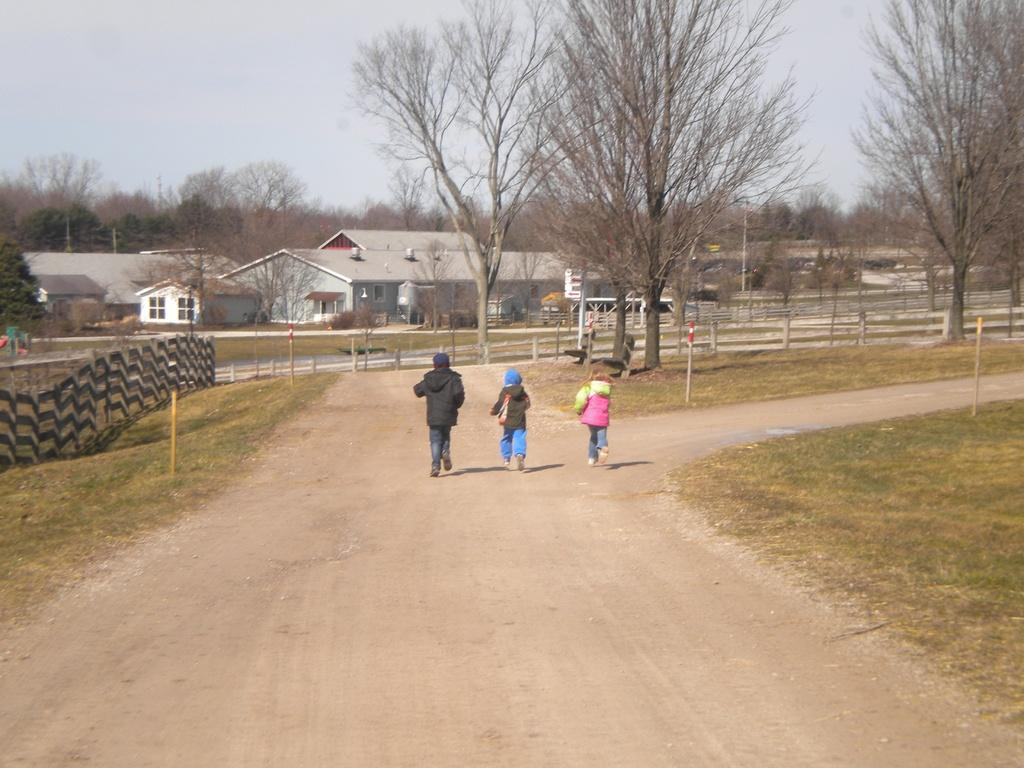How many children are present in the image? There are three children in the image. What are the children doing in the image? The children are running on the road. What type of vegetation can be seen in the image? There are trees in the image. What type of structures are visible in the image? There are buildings with windows in the image. What is the ground surface like in the image? There is grass in the image. What is visible in the background of the image? The sky is visible in the background of the image. What type of flag is being waved by the children in the image? There is no flag visible in the image; the children are running without any flags. 